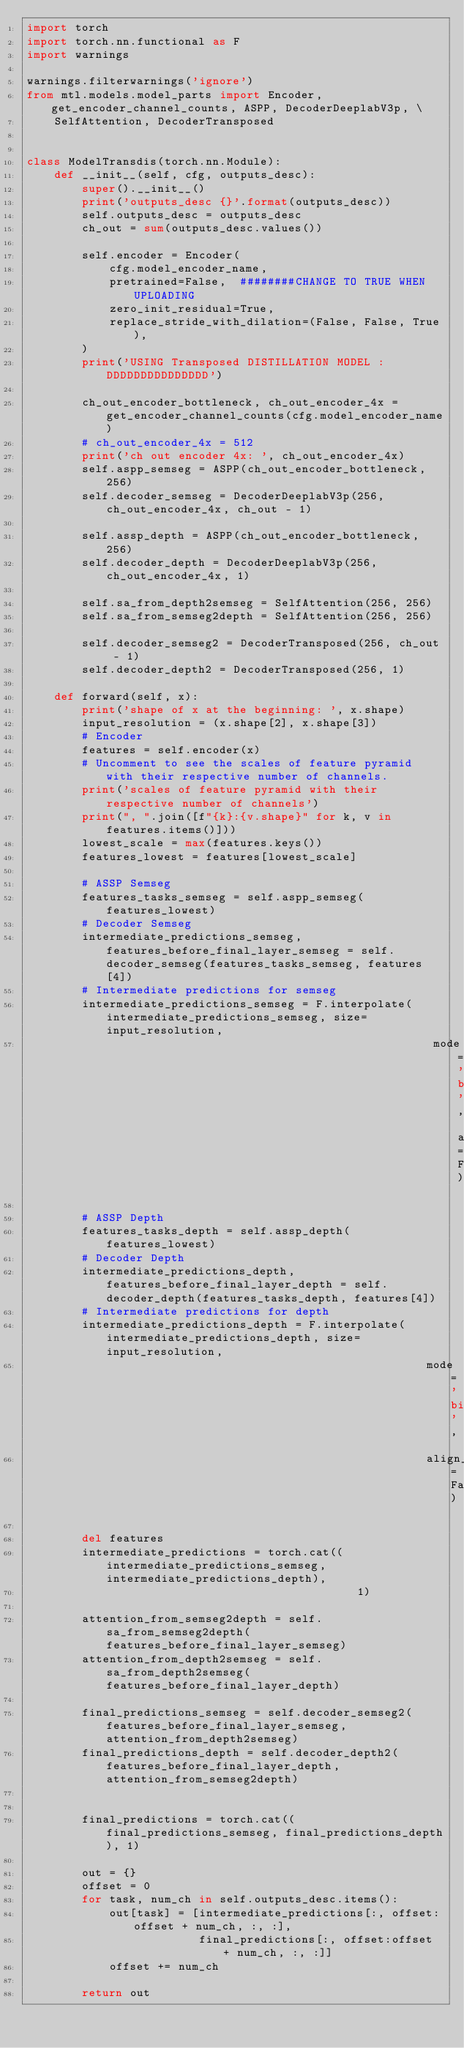<code> <loc_0><loc_0><loc_500><loc_500><_Python_>import torch
import torch.nn.functional as F
import warnings

warnings.filterwarnings('ignore')
from mtl.models.model_parts import Encoder, get_encoder_channel_counts, ASPP, DecoderDeeplabV3p, \
    SelfAttention, DecoderTransposed


class ModelTransdis(torch.nn.Module):
    def __init__(self, cfg, outputs_desc):
        super().__init__()
        print('outputs_desc {}'.format(outputs_desc))
        self.outputs_desc = outputs_desc
        ch_out = sum(outputs_desc.values())

        self.encoder = Encoder(
            cfg.model_encoder_name,
            pretrained=False,  ########CHANGE TO TRUE WHEN UPLOADING
            zero_init_residual=True,
            replace_stride_with_dilation=(False, False, True),
        )
        print('USING Transposed DISTILLATION MODEL :DDDDDDDDDDDDDDD')

        ch_out_encoder_bottleneck, ch_out_encoder_4x = get_encoder_channel_counts(cfg.model_encoder_name)
        # ch_out_encoder_4x = 512
        print('ch out encoder 4x: ', ch_out_encoder_4x)
        self.aspp_semseg = ASPP(ch_out_encoder_bottleneck, 256)
        self.decoder_semseg = DecoderDeeplabV3p(256, ch_out_encoder_4x, ch_out - 1)

        self.assp_depth = ASPP(ch_out_encoder_bottleneck, 256)
        self.decoder_depth = DecoderDeeplabV3p(256, ch_out_encoder_4x, 1)

        self.sa_from_depth2semseg = SelfAttention(256, 256)
        self.sa_from_semseg2depth = SelfAttention(256, 256)

        self.decoder_semseg2 = DecoderTransposed(256, ch_out - 1)
        self.decoder_depth2 = DecoderTransposed(256, 1)

    def forward(self, x):
        print('shape of x at the beginning: ', x.shape)
        input_resolution = (x.shape[2], x.shape[3])
        # Encoder
        features = self.encoder(x)
        # Uncomment to see the scales of feature pyramid with their respective number of channels.
        print('scales of feature pyramid with their respective number of channels')
        print(", ".join([f"{k}:{v.shape}" for k, v in features.items()]))
        lowest_scale = max(features.keys())
        features_lowest = features[lowest_scale]

        # ASSP Semseg
        features_tasks_semseg = self.aspp_semseg(features_lowest)
        # Decoder Semseg
        intermediate_predictions_semseg, features_before_final_layer_semseg = self.decoder_semseg(features_tasks_semseg, features[4])
        # Intermediate predictions for semseg
        intermediate_predictions_semseg = F.interpolate(intermediate_predictions_semseg, size=input_resolution,
                                                           mode='bilinear', align_corners=False)

        # ASSP Depth
        features_tasks_depth = self.assp_depth(features_lowest)
        # Decoder Depth
        intermediate_predictions_depth, features_before_final_layer_depth = self.decoder_depth(features_tasks_depth, features[4])
        # Intermediate predictions for depth
        intermediate_predictions_depth = F.interpolate(intermediate_predictions_depth, size=input_resolution,
                                                          mode='bilinear',
                                                          align_corners=False)

        del features
        intermediate_predictions = torch.cat((intermediate_predictions_semseg, intermediate_predictions_depth),
                                                1)

        attention_from_semseg2depth = self.sa_from_semseg2depth(features_before_final_layer_semseg)
        attention_from_depth2semseg = self.sa_from_depth2semseg(features_before_final_layer_depth)

        final_predictions_semseg = self.decoder_semseg2(features_before_final_layer_semseg, attention_from_depth2semseg)
        final_predictions_depth = self.decoder_depth2(features_before_final_layer_depth, attention_from_semseg2depth)


        final_predictions = torch.cat((final_predictions_semseg, final_predictions_depth), 1)

        out = {}
        offset = 0
        for task, num_ch in self.outputs_desc.items():
            out[task] = [intermediate_predictions[:, offset:offset + num_ch, :, :],
                         final_predictions[:, offset:offset + num_ch, :, :]]
            offset += num_ch

        return out
</code> 